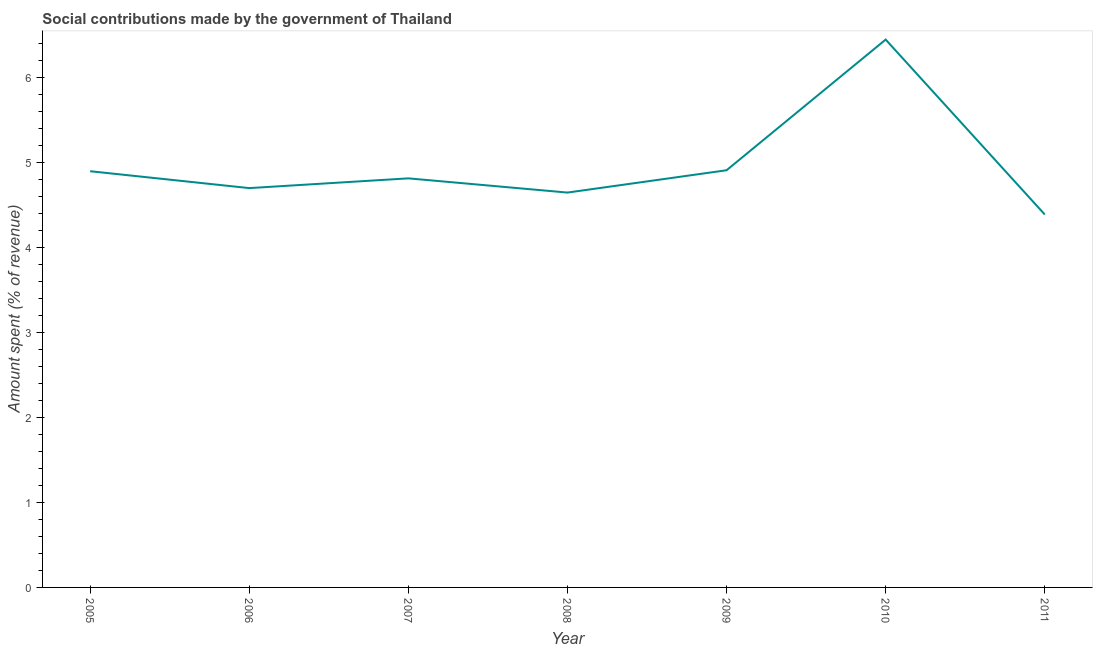What is the amount spent in making social contributions in 2008?
Ensure brevity in your answer.  4.64. Across all years, what is the maximum amount spent in making social contributions?
Your answer should be very brief. 6.44. Across all years, what is the minimum amount spent in making social contributions?
Provide a short and direct response. 4.38. In which year was the amount spent in making social contributions minimum?
Provide a succinct answer. 2011. What is the sum of the amount spent in making social contributions?
Give a very brief answer. 34.77. What is the difference between the amount spent in making social contributions in 2007 and 2008?
Offer a very short reply. 0.17. What is the average amount spent in making social contributions per year?
Your response must be concise. 4.97. What is the median amount spent in making social contributions?
Offer a very short reply. 4.81. In how many years, is the amount spent in making social contributions greater than 4.4 %?
Offer a terse response. 6. What is the ratio of the amount spent in making social contributions in 2007 to that in 2011?
Your response must be concise. 1.1. Is the amount spent in making social contributions in 2007 less than that in 2010?
Provide a short and direct response. Yes. Is the difference between the amount spent in making social contributions in 2005 and 2009 greater than the difference between any two years?
Offer a very short reply. No. What is the difference between the highest and the second highest amount spent in making social contributions?
Make the answer very short. 1.54. Is the sum of the amount spent in making social contributions in 2005 and 2010 greater than the maximum amount spent in making social contributions across all years?
Your answer should be very brief. Yes. What is the difference between the highest and the lowest amount spent in making social contributions?
Your answer should be very brief. 2.06. In how many years, is the amount spent in making social contributions greater than the average amount spent in making social contributions taken over all years?
Keep it short and to the point. 1. Does the amount spent in making social contributions monotonically increase over the years?
Offer a terse response. No. How many lines are there?
Offer a very short reply. 1. How many years are there in the graph?
Your response must be concise. 7. What is the difference between two consecutive major ticks on the Y-axis?
Your answer should be very brief. 1. Are the values on the major ticks of Y-axis written in scientific E-notation?
Make the answer very short. No. Does the graph contain any zero values?
Your answer should be very brief. No. Does the graph contain grids?
Offer a very short reply. No. What is the title of the graph?
Your response must be concise. Social contributions made by the government of Thailand. What is the label or title of the Y-axis?
Give a very brief answer. Amount spent (% of revenue). What is the Amount spent (% of revenue) in 2005?
Your answer should be compact. 4.89. What is the Amount spent (% of revenue) in 2006?
Ensure brevity in your answer.  4.69. What is the Amount spent (% of revenue) of 2007?
Provide a short and direct response. 4.81. What is the Amount spent (% of revenue) in 2008?
Your response must be concise. 4.64. What is the Amount spent (% of revenue) of 2009?
Give a very brief answer. 4.9. What is the Amount spent (% of revenue) in 2010?
Offer a very short reply. 6.44. What is the Amount spent (% of revenue) of 2011?
Provide a succinct answer. 4.38. What is the difference between the Amount spent (% of revenue) in 2005 and 2006?
Provide a succinct answer. 0.2. What is the difference between the Amount spent (% of revenue) in 2005 and 2007?
Your answer should be very brief. 0.08. What is the difference between the Amount spent (% of revenue) in 2005 and 2008?
Provide a succinct answer. 0.25. What is the difference between the Amount spent (% of revenue) in 2005 and 2009?
Ensure brevity in your answer.  -0.01. What is the difference between the Amount spent (% of revenue) in 2005 and 2010?
Your response must be concise. -1.55. What is the difference between the Amount spent (% of revenue) in 2005 and 2011?
Keep it short and to the point. 0.51. What is the difference between the Amount spent (% of revenue) in 2006 and 2007?
Your answer should be compact. -0.11. What is the difference between the Amount spent (% of revenue) in 2006 and 2008?
Provide a succinct answer. 0.05. What is the difference between the Amount spent (% of revenue) in 2006 and 2009?
Your answer should be compact. -0.21. What is the difference between the Amount spent (% of revenue) in 2006 and 2010?
Provide a succinct answer. -1.75. What is the difference between the Amount spent (% of revenue) in 2006 and 2011?
Your response must be concise. 0.31. What is the difference between the Amount spent (% of revenue) in 2007 and 2008?
Your answer should be very brief. 0.17. What is the difference between the Amount spent (% of revenue) in 2007 and 2009?
Provide a short and direct response. -0.1. What is the difference between the Amount spent (% of revenue) in 2007 and 2010?
Provide a short and direct response. -1.63. What is the difference between the Amount spent (% of revenue) in 2007 and 2011?
Make the answer very short. 0.42. What is the difference between the Amount spent (% of revenue) in 2008 and 2009?
Your answer should be compact. -0.26. What is the difference between the Amount spent (% of revenue) in 2008 and 2010?
Provide a short and direct response. -1.8. What is the difference between the Amount spent (% of revenue) in 2008 and 2011?
Offer a terse response. 0.26. What is the difference between the Amount spent (% of revenue) in 2009 and 2010?
Offer a very short reply. -1.54. What is the difference between the Amount spent (% of revenue) in 2009 and 2011?
Your answer should be compact. 0.52. What is the difference between the Amount spent (% of revenue) in 2010 and 2011?
Offer a very short reply. 2.06. What is the ratio of the Amount spent (% of revenue) in 2005 to that in 2006?
Give a very brief answer. 1.04. What is the ratio of the Amount spent (% of revenue) in 2005 to that in 2007?
Keep it short and to the point. 1.02. What is the ratio of the Amount spent (% of revenue) in 2005 to that in 2008?
Ensure brevity in your answer.  1.05. What is the ratio of the Amount spent (% of revenue) in 2005 to that in 2009?
Your response must be concise. 1. What is the ratio of the Amount spent (% of revenue) in 2005 to that in 2010?
Ensure brevity in your answer.  0.76. What is the ratio of the Amount spent (% of revenue) in 2005 to that in 2011?
Offer a very short reply. 1.12. What is the ratio of the Amount spent (% of revenue) in 2006 to that in 2007?
Your answer should be compact. 0.98. What is the ratio of the Amount spent (% of revenue) in 2006 to that in 2008?
Your answer should be very brief. 1.01. What is the ratio of the Amount spent (% of revenue) in 2006 to that in 2009?
Your response must be concise. 0.96. What is the ratio of the Amount spent (% of revenue) in 2006 to that in 2010?
Offer a very short reply. 0.73. What is the ratio of the Amount spent (% of revenue) in 2006 to that in 2011?
Offer a very short reply. 1.07. What is the ratio of the Amount spent (% of revenue) in 2007 to that in 2008?
Provide a succinct answer. 1.04. What is the ratio of the Amount spent (% of revenue) in 2007 to that in 2009?
Provide a succinct answer. 0.98. What is the ratio of the Amount spent (% of revenue) in 2007 to that in 2010?
Ensure brevity in your answer.  0.75. What is the ratio of the Amount spent (% of revenue) in 2007 to that in 2011?
Provide a succinct answer. 1.1. What is the ratio of the Amount spent (% of revenue) in 2008 to that in 2009?
Give a very brief answer. 0.95. What is the ratio of the Amount spent (% of revenue) in 2008 to that in 2010?
Your answer should be compact. 0.72. What is the ratio of the Amount spent (% of revenue) in 2008 to that in 2011?
Provide a short and direct response. 1.06. What is the ratio of the Amount spent (% of revenue) in 2009 to that in 2010?
Offer a very short reply. 0.76. What is the ratio of the Amount spent (% of revenue) in 2009 to that in 2011?
Keep it short and to the point. 1.12. What is the ratio of the Amount spent (% of revenue) in 2010 to that in 2011?
Your answer should be very brief. 1.47. 